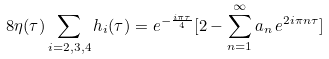Convert formula to latex. <formula><loc_0><loc_0><loc_500><loc_500>8 \eta ( \tau ) \sum _ { i = 2 , 3 , 4 } h _ { i } ( \tau ) = e ^ { - \frac { i \pi \tau } { 4 } } [ 2 - \sum _ { n = 1 } ^ { \infty } a _ { n } \, e ^ { 2 i \pi n \tau } ]</formula> 